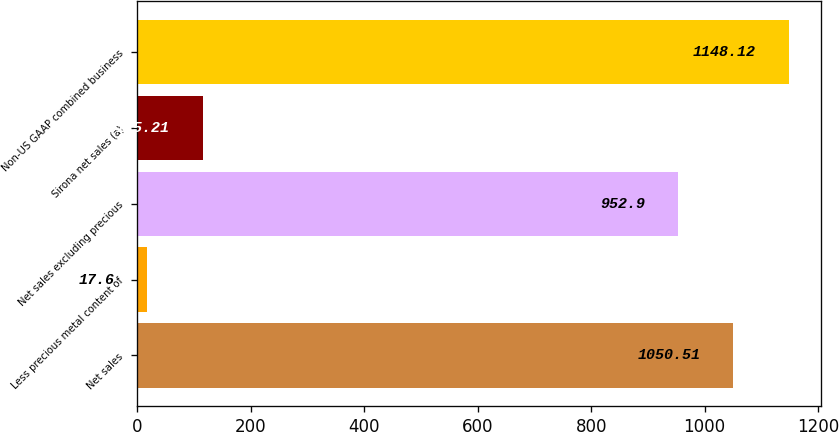Convert chart to OTSL. <chart><loc_0><loc_0><loc_500><loc_500><bar_chart><fcel>Net sales<fcel>Less precious metal content of<fcel>Net sales excluding precious<fcel>Sirona net sales (a)<fcel>Non-US GAAP combined business<nl><fcel>1050.51<fcel>17.6<fcel>952.9<fcel>115.21<fcel>1148.12<nl></chart> 